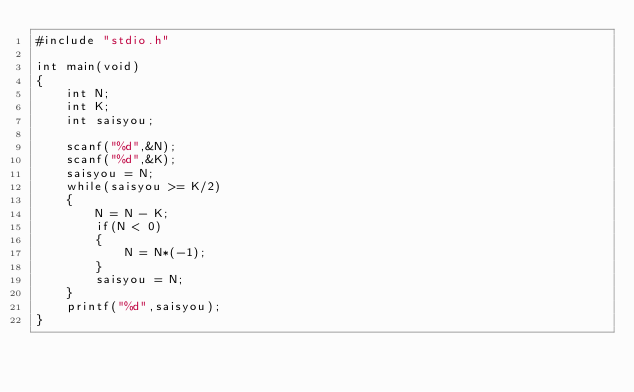<code> <loc_0><loc_0><loc_500><loc_500><_C_>#include "stdio.h"

int main(void)
{
    int N;
    int K;
    int saisyou;

    scanf("%d",&N);
    scanf("%d",&K);
    saisyou = N;
    while(saisyou >= K/2)
    {
        N = N - K;
        if(N < 0)
        {
            N = N*(-1);
        }
        saisyou = N;
    }
    printf("%d",saisyou);
}</code> 